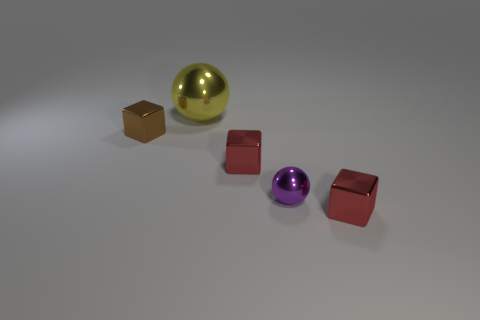Subtract all small red blocks. How many blocks are left? 1 Subtract all purple cylinders. How many red cubes are left? 2 Add 2 small brown metallic things. How many objects exist? 7 Subtract all gray blocks. Subtract all gray spheres. How many blocks are left? 3 Subtract 0 gray spheres. How many objects are left? 5 Subtract all balls. How many objects are left? 3 Subtract all big red balls. Subtract all purple spheres. How many objects are left? 4 Add 5 big metal balls. How many big metal balls are left? 6 Add 1 small brown metal things. How many small brown metal things exist? 2 